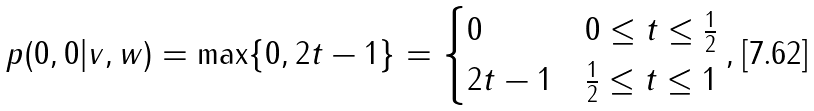<formula> <loc_0><loc_0><loc_500><loc_500>p ( 0 , 0 | v , w ) = \max \{ 0 , 2 t - 1 \} = \begin{cases} 0 & 0 \leq t \leq \frac { 1 } { 2 } \\ 2 t - 1 & \frac { 1 } { 2 } \leq t \leq 1 \end{cases} ,</formula> 